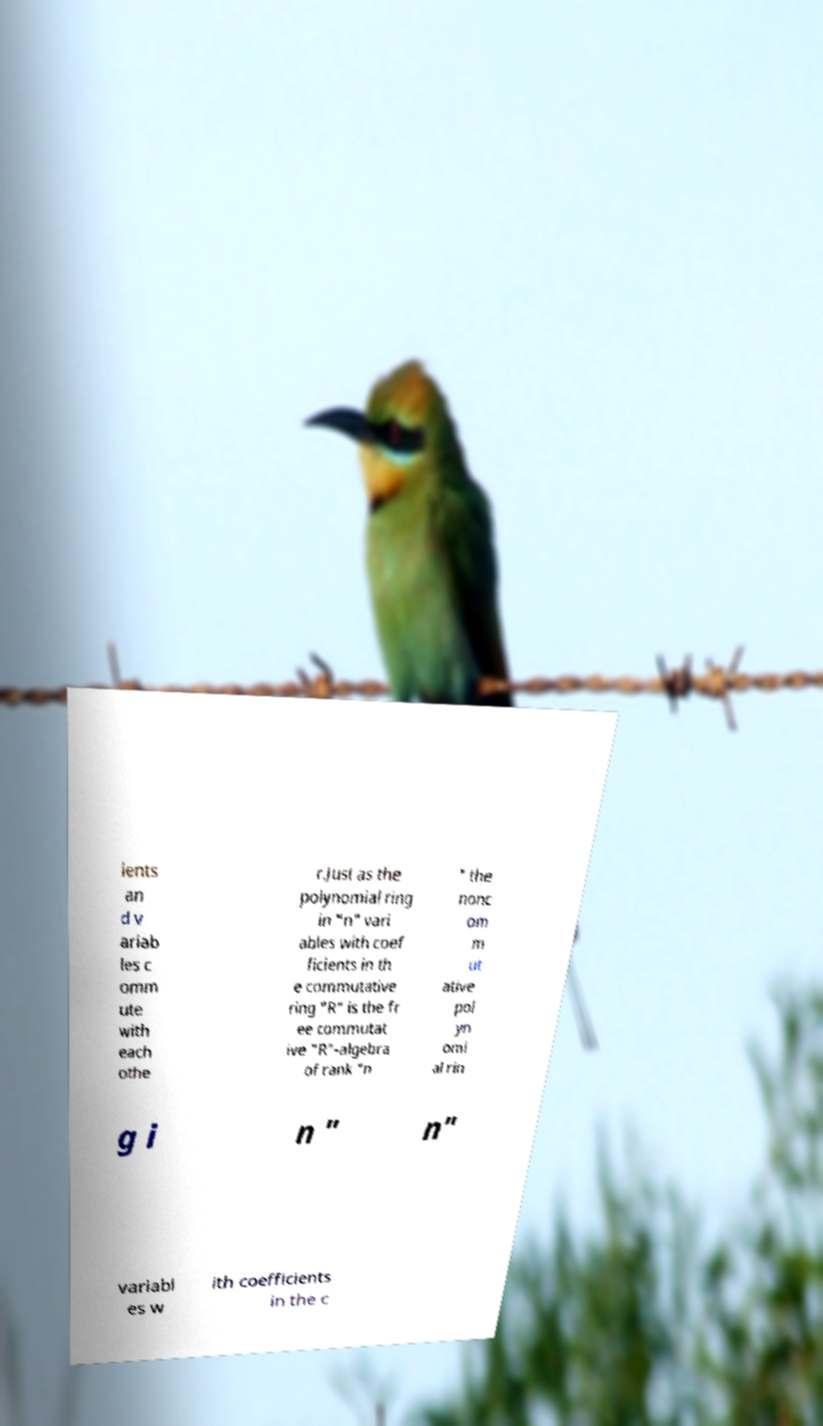Can you read and provide the text displayed in the image?This photo seems to have some interesting text. Can you extract and type it out for me? ients an d v ariab les c omm ute with each othe r.Just as the polynomial ring in "n" vari ables with coef ficients in th e commutative ring "R" is the fr ee commutat ive "R"-algebra of rank "n " the nonc om m ut ative pol yn omi al rin g i n " n" variabl es w ith coefficients in the c 